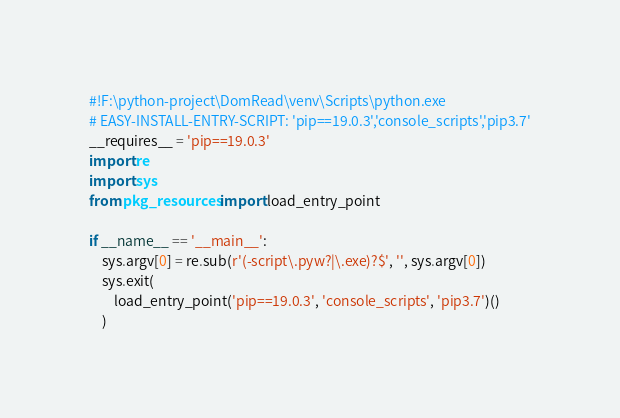Convert code to text. <code><loc_0><loc_0><loc_500><loc_500><_Python_>#!F:\python-project\DomRead\venv\Scripts\python.exe
# EASY-INSTALL-ENTRY-SCRIPT: 'pip==19.0.3','console_scripts','pip3.7'
__requires__ = 'pip==19.0.3'
import re
import sys
from pkg_resources import load_entry_point

if __name__ == '__main__':
    sys.argv[0] = re.sub(r'(-script\.pyw?|\.exe)?$', '', sys.argv[0])
    sys.exit(
        load_entry_point('pip==19.0.3', 'console_scripts', 'pip3.7')()
    )
</code> 